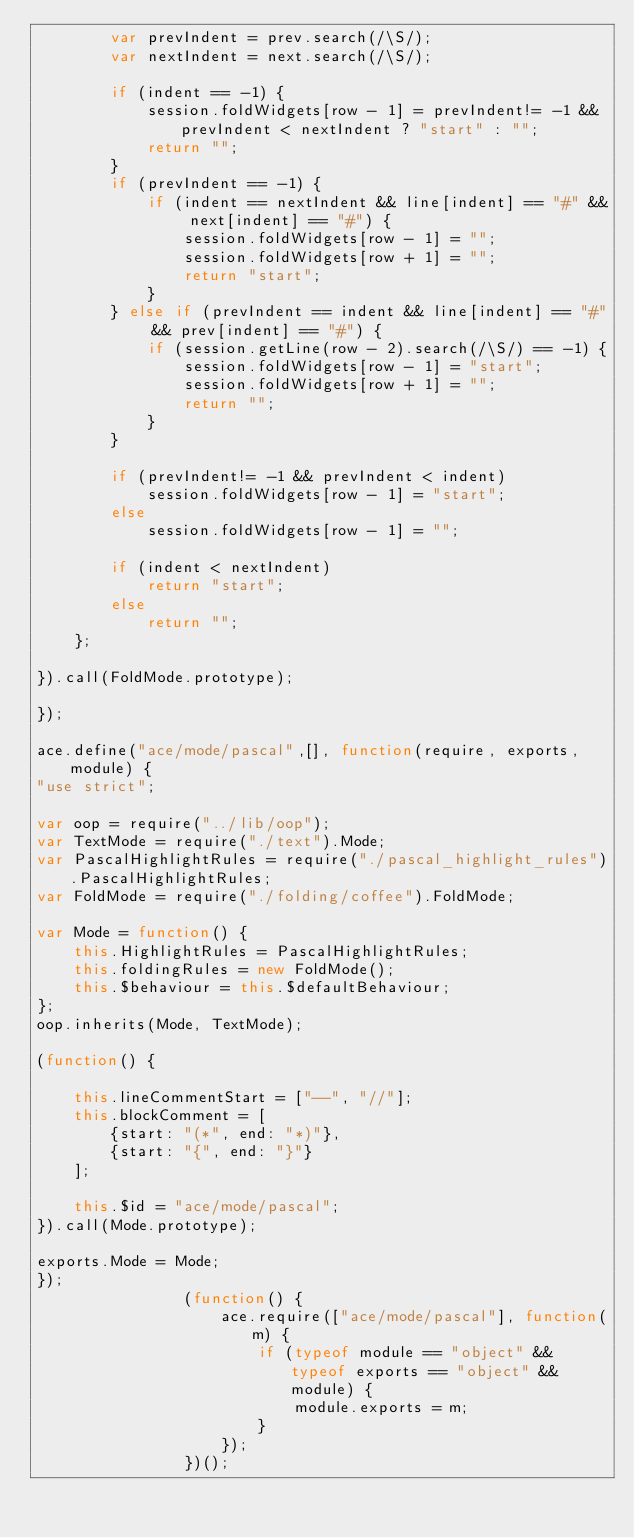<code> <loc_0><loc_0><loc_500><loc_500><_JavaScript_>        var prevIndent = prev.search(/\S/);
        var nextIndent = next.search(/\S/);

        if (indent == -1) {
            session.foldWidgets[row - 1] = prevIndent!= -1 && prevIndent < nextIndent ? "start" : "";
            return "";
        }
        if (prevIndent == -1) {
            if (indent == nextIndent && line[indent] == "#" && next[indent] == "#") {
                session.foldWidgets[row - 1] = "";
                session.foldWidgets[row + 1] = "";
                return "start";
            }
        } else if (prevIndent == indent && line[indent] == "#" && prev[indent] == "#") {
            if (session.getLine(row - 2).search(/\S/) == -1) {
                session.foldWidgets[row - 1] = "start";
                session.foldWidgets[row + 1] = "";
                return "";
            }
        }

        if (prevIndent!= -1 && prevIndent < indent)
            session.foldWidgets[row - 1] = "start";
        else
            session.foldWidgets[row - 1] = "";

        if (indent < nextIndent)
            return "start";
        else
            return "";
    };

}).call(FoldMode.prototype);

});

ace.define("ace/mode/pascal",[], function(require, exports, module) {
"use strict";

var oop = require("../lib/oop");
var TextMode = require("./text").Mode;
var PascalHighlightRules = require("./pascal_highlight_rules").PascalHighlightRules;
var FoldMode = require("./folding/coffee").FoldMode;

var Mode = function() {
    this.HighlightRules = PascalHighlightRules;
    this.foldingRules = new FoldMode();
    this.$behaviour = this.$defaultBehaviour;
};
oop.inherits(Mode, TextMode);

(function() {
       
    this.lineCommentStart = ["--", "//"];
    this.blockComment = [
        {start: "(*", end: "*)"},
        {start: "{", end: "}"}
    ];
    
    this.$id = "ace/mode/pascal";
}).call(Mode.prototype);

exports.Mode = Mode;
});
                (function() {
                    ace.require(["ace/mode/pascal"], function(m) {
                        if (typeof module == "object" && typeof exports == "object" && module) {
                            module.exports = m;
                        }
                    });
                })();
            </code> 